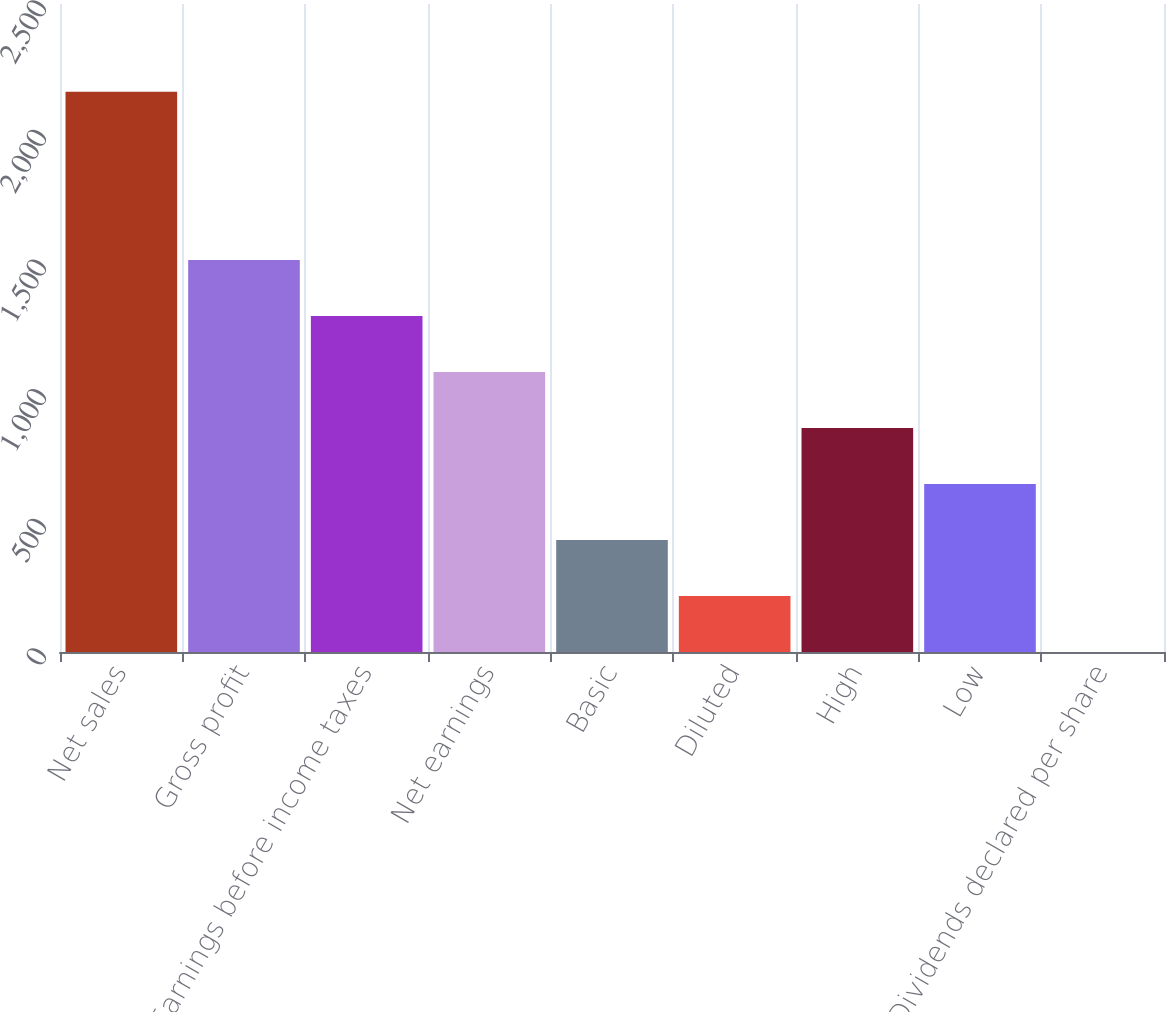Convert chart. <chart><loc_0><loc_0><loc_500><loc_500><bar_chart><fcel>Net sales<fcel>Gross profit<fcel>Earnings before income taxes<fcel>Net earnings<fcel>Basic<fcel>Diluted<fcel>High<fcel>Low<fcel>Dividends declared per share<nl><fcel>2161<fcel>1512.77<fcel>1296.69<fcel>1080.61<fcel>432.37<fcel>216.29<fcel>864.53<fcel>648.45<fcel>0.21<nl></chart> 